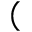<formula> <loc_0><loc_0><loc_500><loc_500>(</formula> 